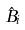<formula> <loc_0><loc_0><loc_500><loc_500>\hat { B } _ { i }</formula> 